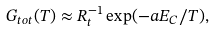<formula> <loc_0><loc_0><loc_500><loc_500>G _ { t o t } ( T ) \approx R _ { t } ^ { - 1 } \exp ( - a E _ { C } / T ) ,</formula> 